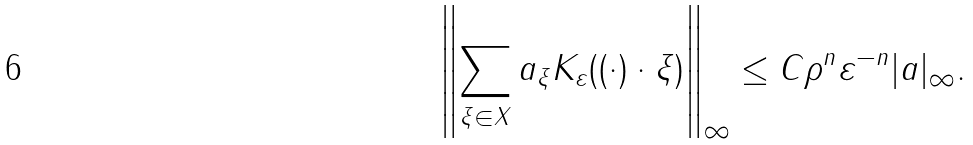Convert formula to latex. <formula><loc_0><loc_0><loc_500><loc_500>\left \| \sum _ { \xi \in X } a _ { \xi } K _ { \varepsilon } ( ( \cdot ) \cdot \xi ) \right \| _ { \infty } \leq C \rho ^ { n } \varepsilon ^ { - n } | a | _ { \infty } .</formula> 